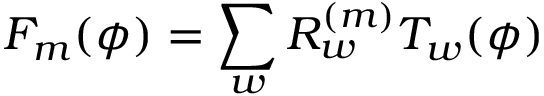Convert formula to latex. <formula><loc_0><loc_0><loc_500><loc_500>F _ { m } ( \phi ) = \sum _ { w } R _ { w } ^ { ( m ) } T _ { w } ( \phi )</formula> 